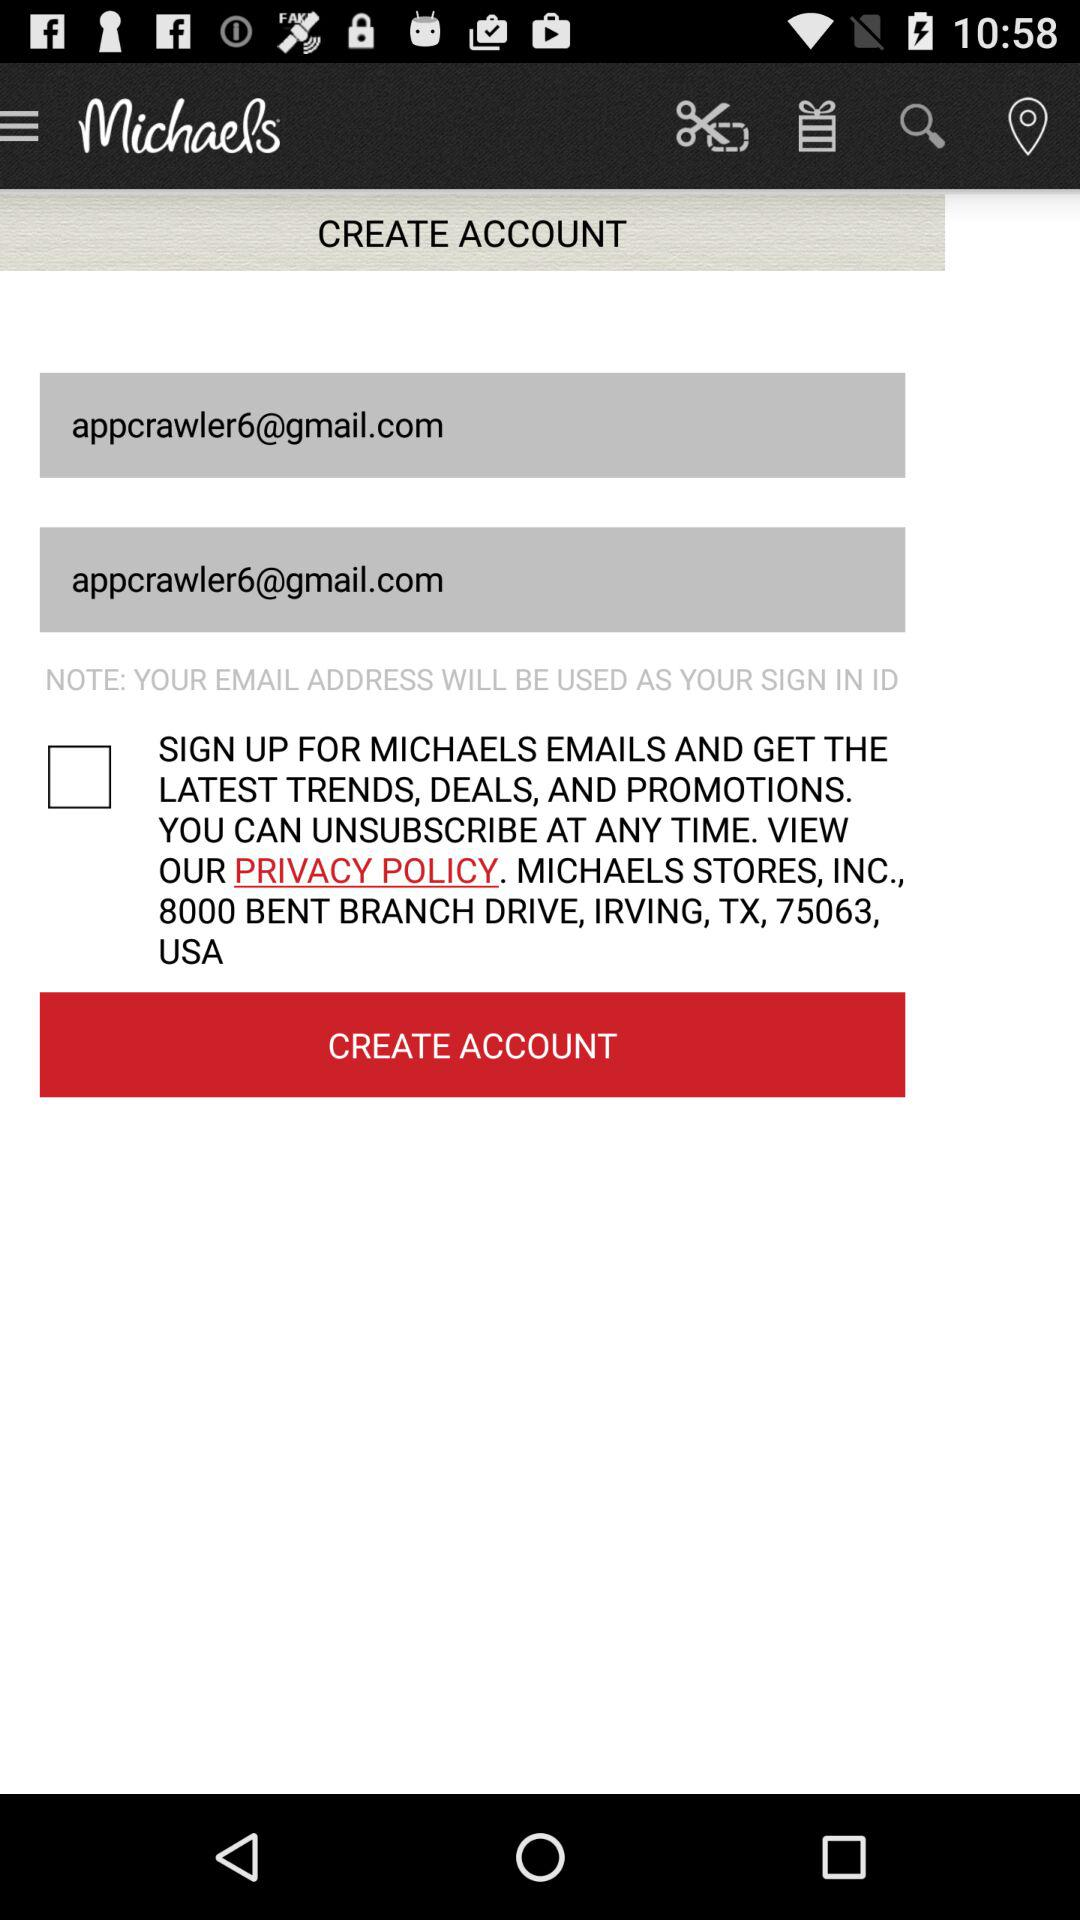Where is the nearest Michaels location?
When the provided information is insufficient, respond with <no answer>. <no answer> 